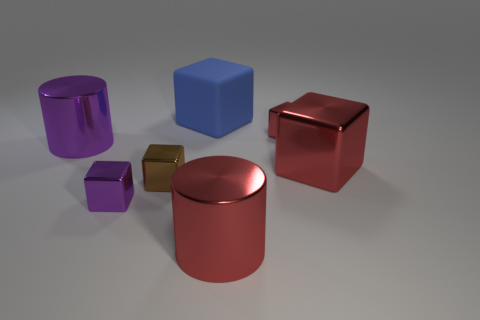Subtract all small brown cubes. How many cubes are left? 4 Add 2 large rubber objects. How many objects exist? 9 Subtract all yellow balls. How many red cubes are left? 2 Subtract all purple cylinders. How many cylinders are left? 1 Add 2 big metallic things. How many big metallic things are left? 5 Add 2 large blue matte things. How many large blue matte things exist? 3 Subtract 1 blue cubes. How many objects are left? 6 Subtract all cubes. How many objects are left? 2 Subtract all blue cubes. Subtract all green balls. How many cubes are left? 4 Subtract all blue matte things. Subtract all large purple things. How many objects are left? 5 